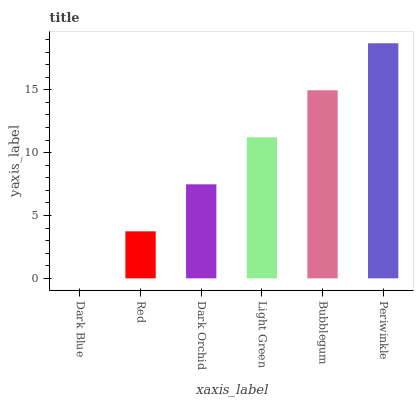Is Red the minimum?
Answer yes or no. No. Is Red the maximum?
Answer yes or no. No. Is Red greater than Dark Blue?
Answer yes or no. Yes. Is Dark Blue less than Red?
Answer yes or no. Yes. Is Dark Blue greater than Red?
Answer yes or no. No. Is Red less than Dark Blue?
Answer yes or no. No. Is Light Green the high median?
Answer yes or no. Yes. Is Dark Orchid the low median?
Answer yes or no. Yes. Is Periwinkle the high median?
Answer yes or no. No. Is Dark Blue the low median?
Answer yes or no. No. 